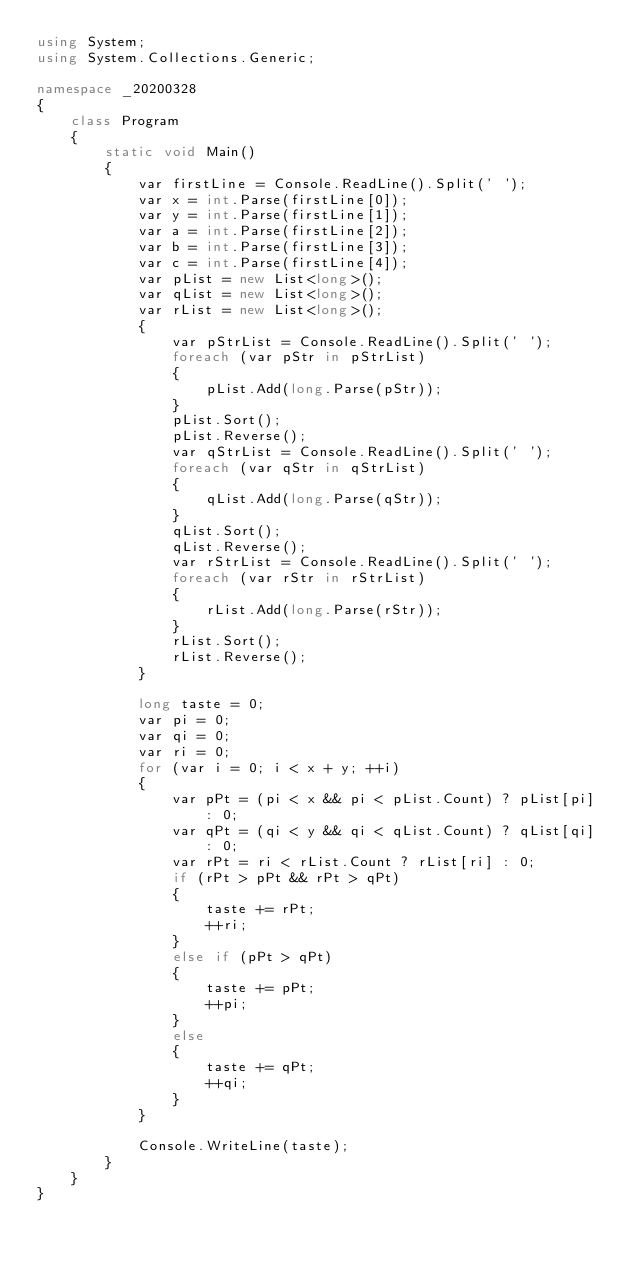Convert code to text. <code><loc_0><loc_0><loc_500><loc_500><_C#_>using System;
using System.Collections.Generic;

namespace _20200328
{
    class Program
    {
        static void Main()
        {
            var firstLine = Console.ReadLine().Split(' ');
            var x = int.Parse(firstLine[0]);
            var y = int.Parse(firstLine[1]);
            var a = int.Parse(firstLine[2]);
            var b = int.Parse(firstLine[3]);
            var c = int.Parse(firstLine[4]);
            var pList = new List<long>();
            var qList = new List<long>();
            var rList = new List<long>();
            {
                var pStrList = Console.ReadLine().Split(' ');
                foreach (var pStr in pStrList)
                {
                    pList.Add(long.Parse(pStr));
                }
                pList.Sort();
                pList.Reverse();
                var qStrList = Console.ReadLine().Split(' ');
                foreach (var qStr in qStrList)
                {
                    qList.Add(long.Parse(qStr));
                }
                qList.Sort();
                qList.Reverse();
                var rStrList = Console.ReadLine().Split(' ');
                foreach (var rStr in rStrList)
                {
                    rList.Add(long.Parse(rStr));
                }
                rList.Sort();
                rList.Reverse();
            }
            
            long taste = 0;
            var pi = 0;
            var qi = 0;
            var ri = 0;
            for (var i = 0; i < x + y; ++i)
            {
                var pPt = (pi < x && pi < pList.Count) ? pList[pi] : 0;
                var qPt = (qi < y && qi < qList.Count) ? qList[qi] : 0;
                var rPt = ri < rList.Count ? rList[ri] : 0;
                if (rPt > pPt && rPt > qPt)
                {
                    taste += rPt;
                    ++ri;
                }
                else if (pPt > qPt)
                {
                    taste += pPt;
                    ++pi;
                }
                else
                {
                    taste += qPt;
                    ++qi;
                }
            }

            Console.WriteLine(taste);
        }
    }
}
</code> 